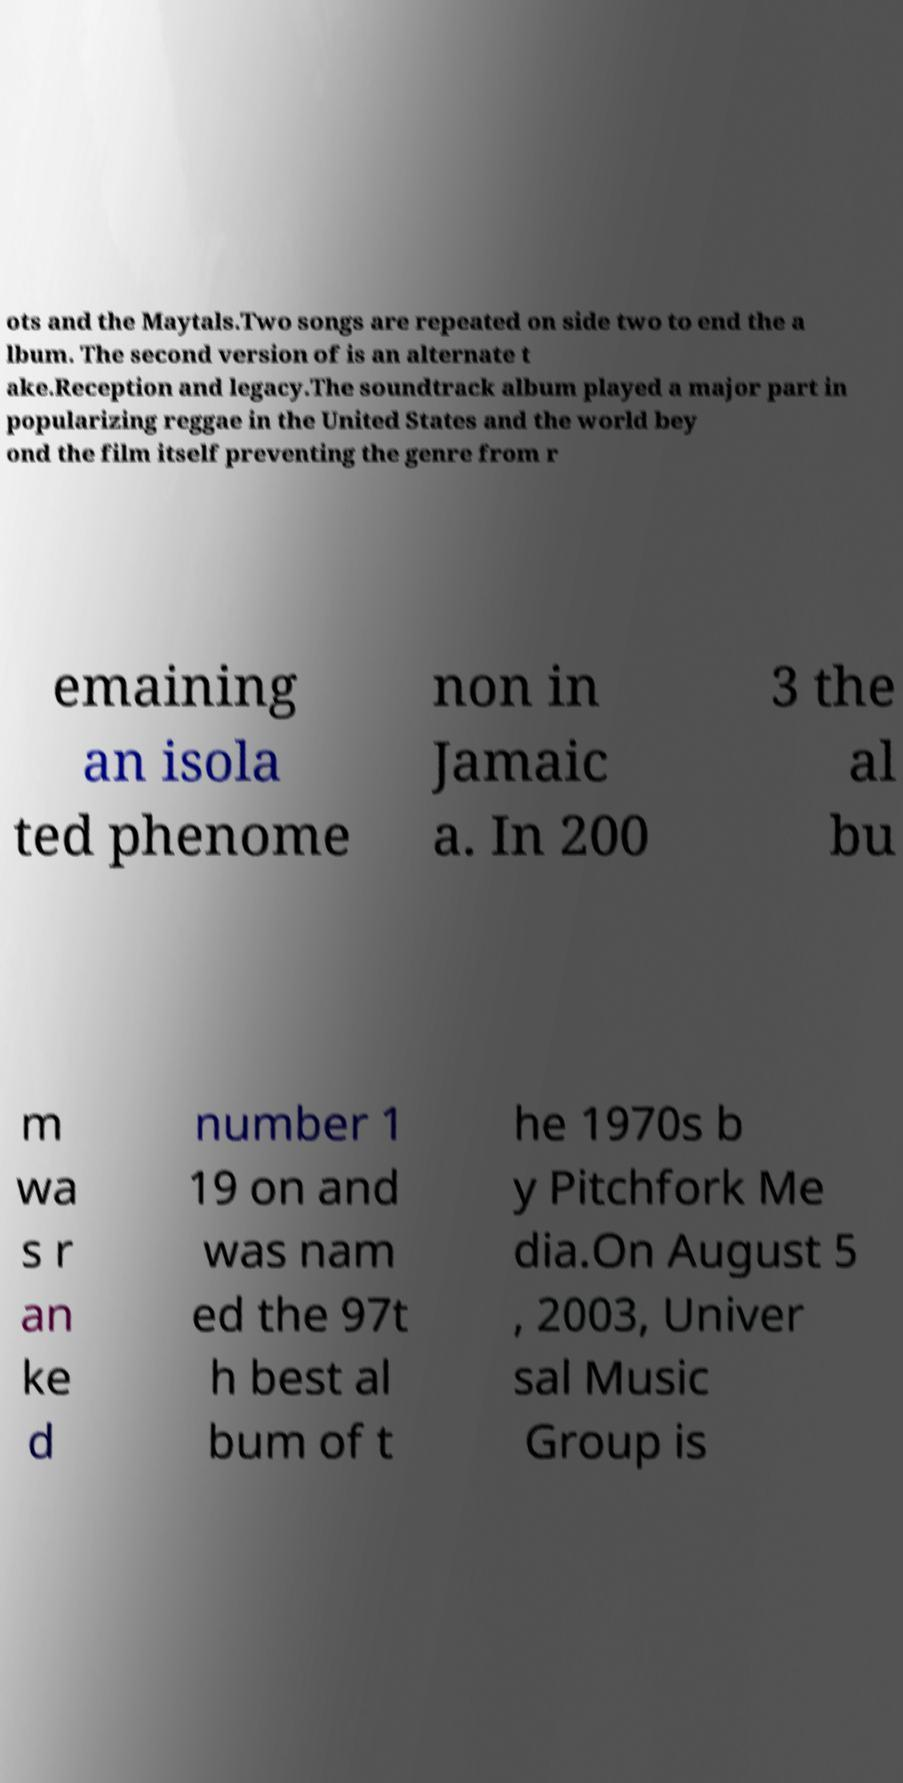There's text embedded in this image that I need extracted. Can you transcribe it verbatim? ots and the Maytals.Two songs are repeated on side two to end the a lbum. The second version of is an alternate t ake.Reception and legacy.The soundtrack album played a major part in popularizing reggae in the United States and the world bey ond the film itself preventing the genre from r emaining an isola ted phenome non in Jamaic a. In 200 3 the al bu m wa s r an ke d number 1 19 on and was nam ed the 97t h best al bum of t he 1970s b y Pitchfork Me dia.On August 5 , 2003, Univer sal Music Group is 